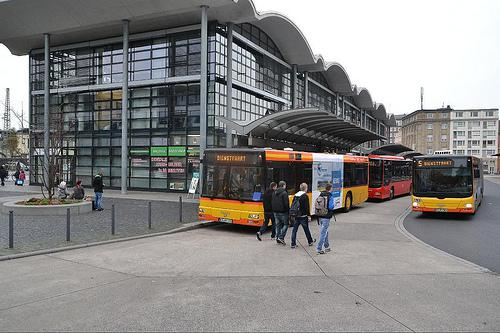Question: how many buses are in the picture?
Choices:
A. 2.
B. 3.
C. 1.
D. 0.
Answer with the letter. Answer: B Question: how many people are on the street in the middle of the picture?
Choices:
A. 3.
B. 2.
C. 4.
D. 1.
Answer with the letter. Answer: C Question: what color is the bus in back?
Choices:
A. Black.
B. Yellow.
C. Red.
D. Blue.
Answer with the letter. Answer: C Question: what type of shelter are the buses stopped at?
Choices:
A. A restaurant.
B. A museum.
C. A bus stop.
D. A gallery.
Answer with the letter. Answer: C Question: how many stories is the building to the right of the buses?
Choices:
A. 2.
B. 3.
C. 1.
D. 0.
Answer with the letter. Answer: B Question: what does the right-most person have on their back?
Choices:
A. A backpack.
B. A camera.
C. A guitar.
D. A uke.
Answer with the letter. Answer: A Question: how many buses have orange fronts?
Choices:
A. 2.
B. 1.
C. 3.
D. 4.
Answer with the letter. Answer: A 